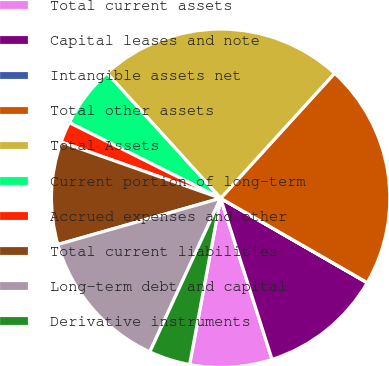<chart> <loc_0><loc_0><loc_500><loc_500><pie_chart><fcel>Total current assets<fcel>Capital leases and note<fcel>Intangible assets net<fcel>Total other assets<fcel>Total Assets<fcel>Current portion of long-term<fcel>Accrued expenses and other<fcel>Total current liabilities<fcel>Long-term debt and capital<fcel>Derivative instruments<nl><fcel>7.85%<fcel>11.76%<fcel>0.02%<fcel>21.54%<fcel>23.5%<fcel>5.89%<fcel>1.98%<fcel>9.8%<fcel>13.72%<fcel>3.94%<nl></chart> 